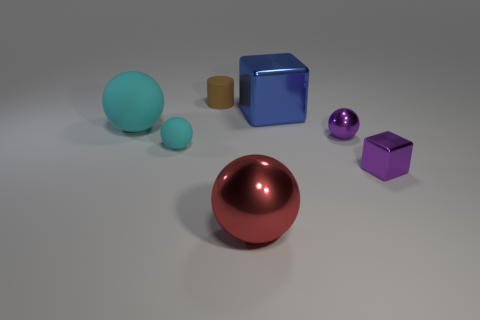Subtract all purple balls. How many balls are left? 3 Add 2 cyan metallic blocks. How many objects exist? 9 Subtract all blue cylinders. How many cyan spheres are left? 2 Subtract all blue cubes. How many cubes are left? 1 Add 7 red metallic objects. How many red metallic objects exist? 8 Subtract 0 yellow spheres. How many objects are left? 7 Subtract all blocks. How many objects are left? 5 Subtract 1 balls. How many balls are left? 3 Subtract all blue blocks. Subtract all green cylinders. How many blocks are left? 1 Subtract all big cyan things. Subtract all small rubber spheres. How many objects are left? 5 